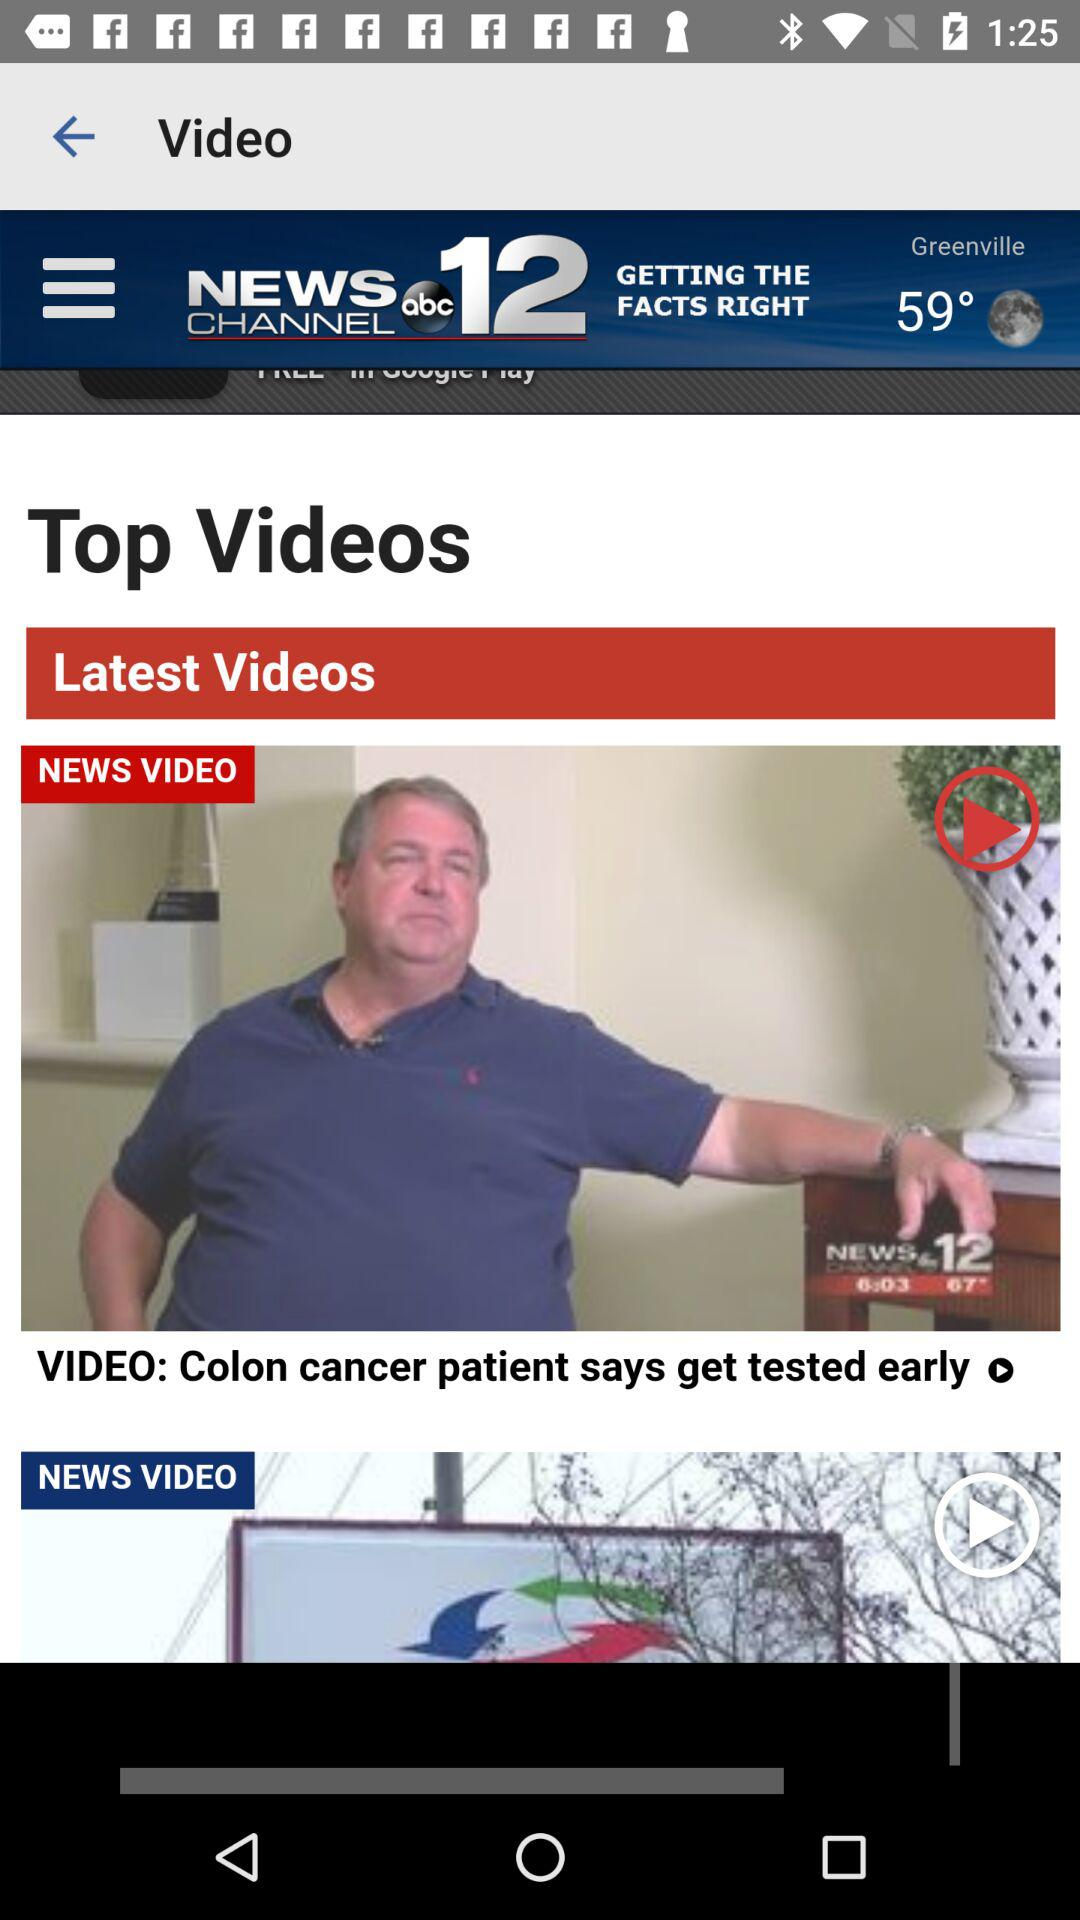What is the temperature? The temperature is 59°. 